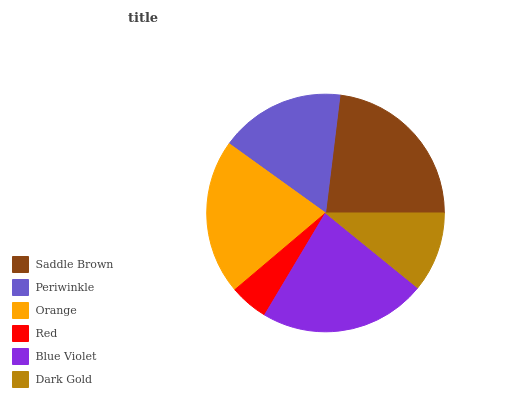Is Red the minimum?
Answer yes or no. Yes. Is Saddle Brown the maximum?
Answer yes or no. Yes. Is Periwinkle the minimum?
Answer yes or no. No. Is Periwinkle the maximum?
Answer yes or no. No. Is Saddle Brown greater than Periwinkle?
Answer yes or no. Yes. Is Periwinkle less than Saddle Brown?
Answer yes or no. Yes. Is Periwinkle greater than Saddle Brown?
Answer yes or no. No. Is Saddle Brown less than Periwinkle?
Answer yes or no. No. Is Orange the high median?
Answer yes or no. Yes. Is Periwinkle the low median?
Answer yes or no. Yes. Is Dark Gold the high median?
Answer yes or no. No. Is Blue Violet the low median?
Answer yes or no. No. 